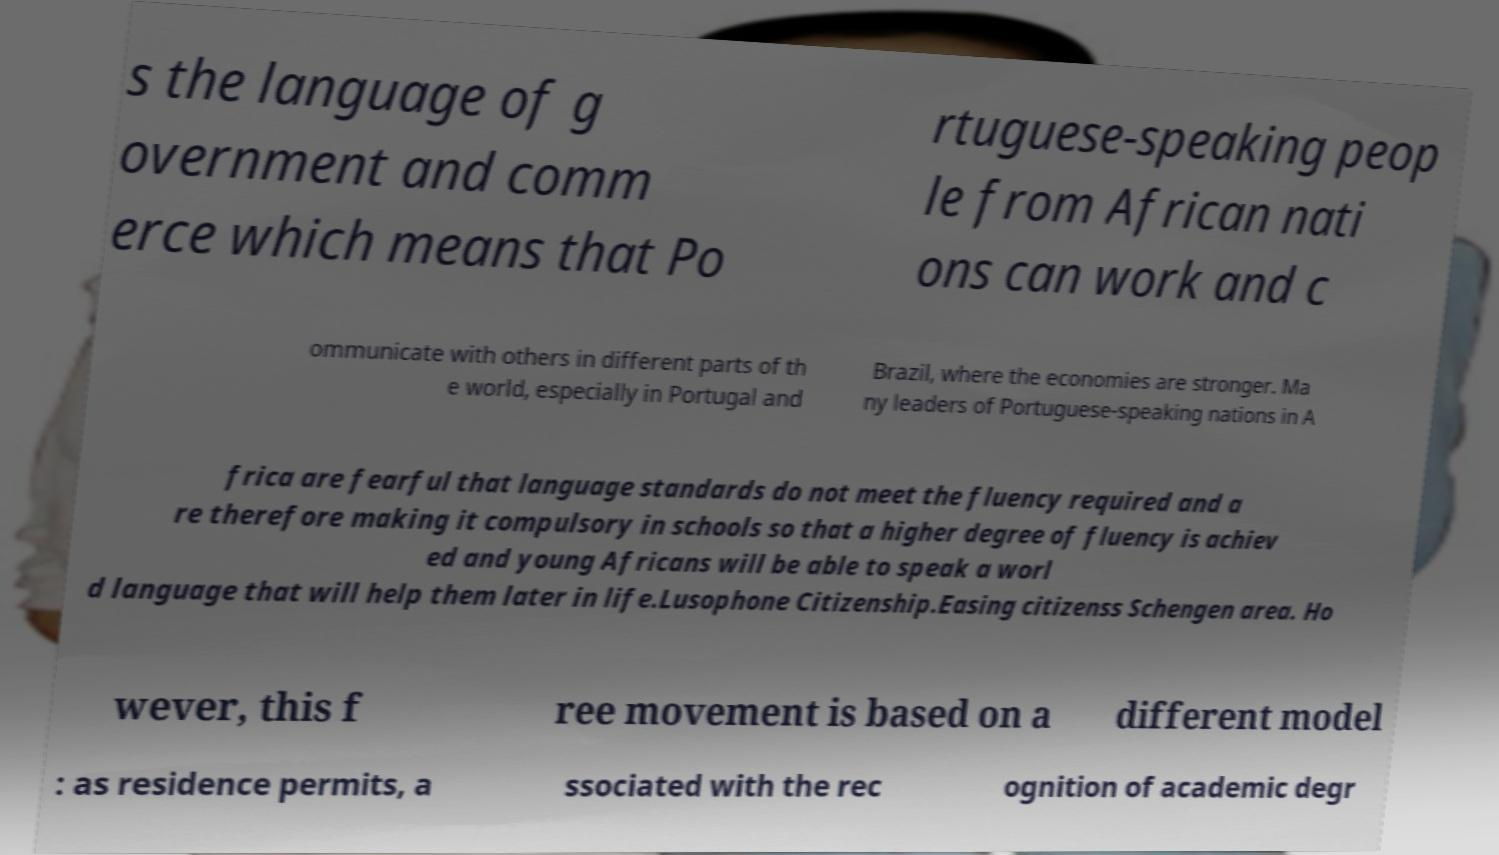I need the written content from this picture converted into text. Can you do that? s the language of g overnment and comm erce which means that Po rtuguese-speaking peop le from African nati ons can work and c ommunicate with others in different parts of th e world, especially in Portugal and Brazil, where the economies are stronger. Ma ny leaders of Portuguese-speaking nations in A frica are fearful that language standards do not meet the fluency required and a re therefore making it compulsory in schools so that a higher degree of fluency is achiev ed and young Africans will be able to speak a worl d language that will help them later in life.Lusophone Citizenship.Easing citizenss Schengen area. Ho wever, this f ree movement is based on a different model : as residence permits, a ssociated with the rec ognition of academic degr 